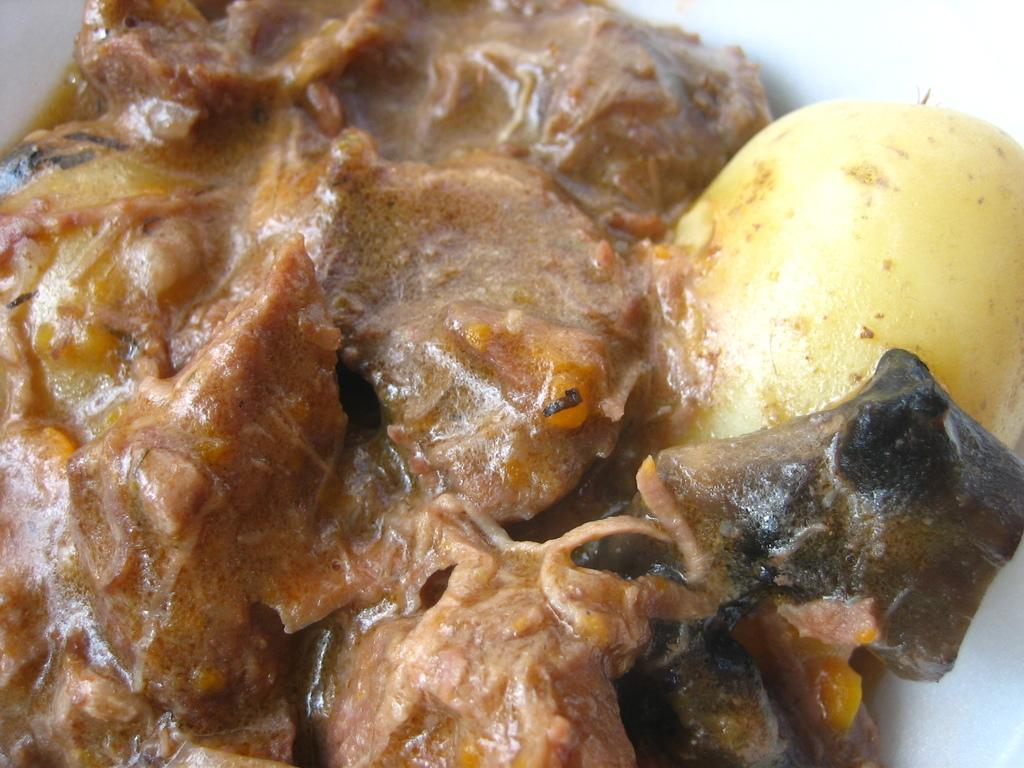What is the main subject of the image? There is a food item in the image. How many people are in the crowd surrounding the food item in the image? There is no crowd present in the image, as it only features a food item. 